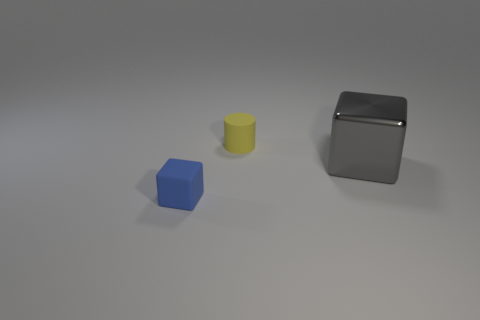There is a block to the right of the small thing that is behind the small object that is to the left of the tiny yellow rubber thing; what is it made of?
Keep it short and to the point. Metal. Does the yellow matte cylinder have the same size as the blue object?
Provide a short and direct response. Yes. What is the shape of the blue thing that is the same material as the small cylinder?
Your answer should be very brief. Cube. There is a object on the left side of the yellow object; does it have the same shape as the large shiny thing?
Provide a succinct answer. Yes. There is a cube that is to the right of the tiny matte thing that is behind the gray object; how big is it?
Make the answer very short. Large. There is a block that is the same material as the tiny cylinder; what color is it?
Provide a succinct answer. Blue. What number of cylinders have the same size as the rubber cube?
Provide a short and direct response. 1. How many brown things are big metal objects or tiny rubber objects?
Provide a short and direct response. 0. How many things are big blue metallic things or matte objects that are on the left side of the tiny yellow rubber cylinder?
Your response must be concise. 1. There is a thing that is behind the large cube; what is it made of?
Your response must be concise. Rubber. 